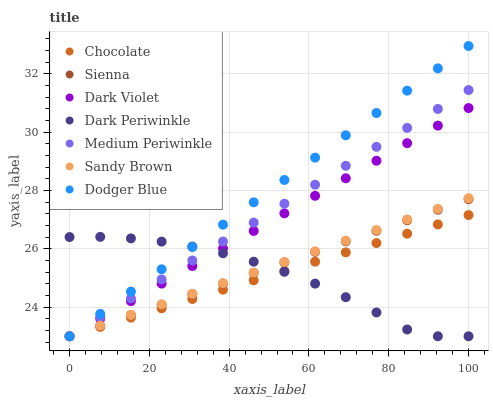Does Dark Periwinkle have the minimum area under the curve?
Answer yes or no. Yes. Does Dodger Blue have the maximum area under the curve?
Answer yes or no. Yes. Does Dark Violet have the minimum area under the curve?
Answer yes or no. No. Does Dark Violet have the maximum area under the curve?
Answer yes or no. No. Is Sandy Brown the smoothest?
Answer yes or no. Yes. Is Dark Periwinkle the roughest?
Answer yes or no. Yes. Is Dark Violet the smoothest?
Answer yes or no. No. Is Dark Violet the roughest?
Answer yes or no. No. Does Medium Periwinkle have the lowest value?
Answer yes or no. Yes. Does Dodger Blue have the highest value?
Answer yes or no. Yes. Does Dark Violet have the highest value?
Answer yes or no. No. Does Medium Periwinkle intersect Sandy Brown?
Answer yes or no. Yes. Is Medium Periwinkle less than Sandy Brown?
Answer yes or no. No. Is Medium Periwinkle greater than Sandy Brown?
Answer yes or no. No. 